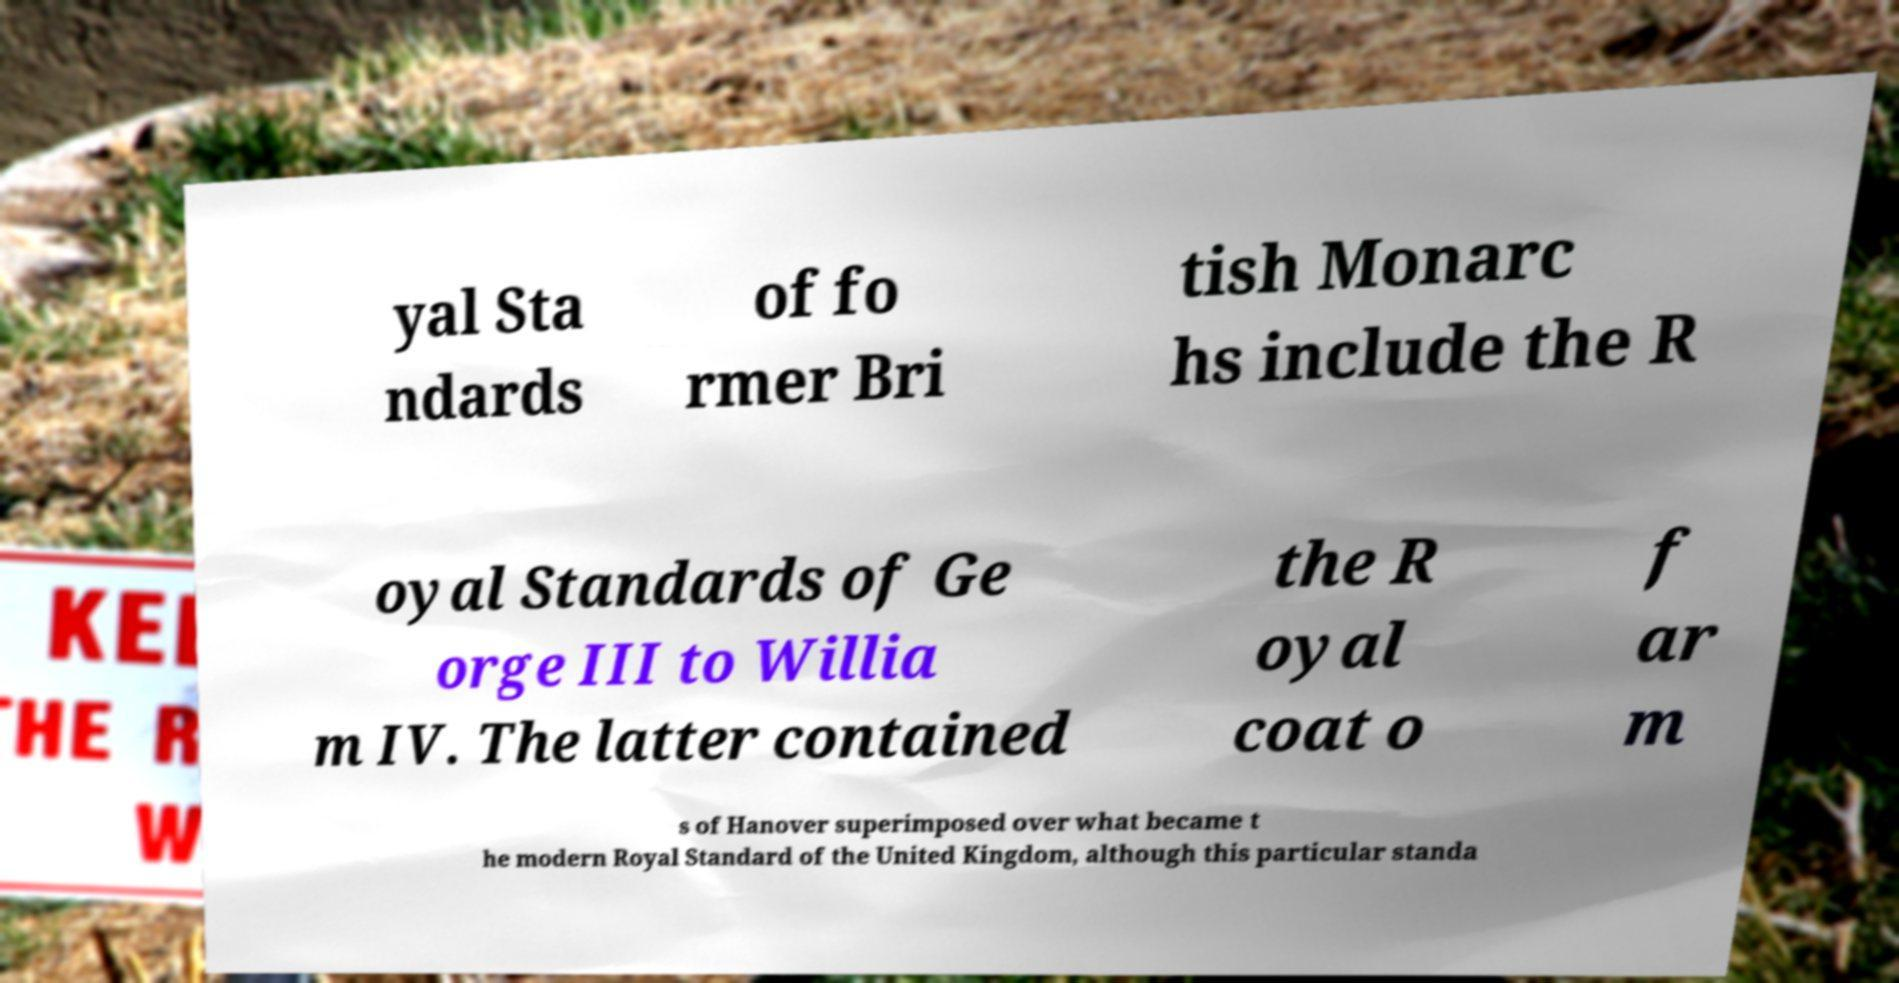Can you read and provide the text displayed in the image?This photo seems to have some interesting text. Can you extract and type it out for me? yal Sta ndards of fo rmer Bri tish Monarc hs include the R oyal Standards of Ge orge III to Willia m IV. The latter contained the R oyal coat o f ar m s of Hanover superimposed over what became t he modern Royal Standard of the United Kingdom, although this particular standa 